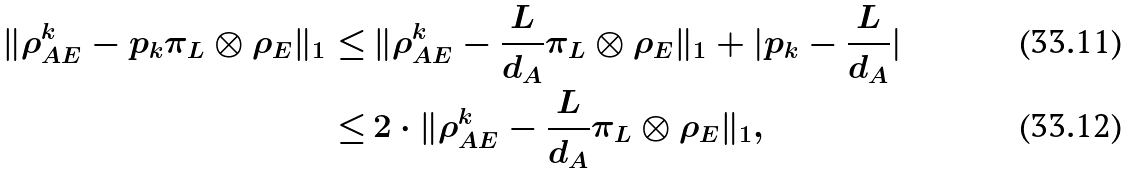<formula> <loc_0><loc_0><loc_500><loc_500>\| \rho _ { A E } ^ { k } - p _ { k } \pi _ { L } \otimes \rho _ { E } \| _ { 1 } \leq & \, \| \rho _ { A E } ^ { k } - \frac { L } { d _ { A } } \pi _ { L } \otimes \rho _ { E } \| _ { 1 } + | p _ { k } - \frac { L } { d _ { A } } | \\ \leq & \, 2 \cdot \| \rho _ { A E } ^ { k } - \frac { L } { d _ { A } } \pi _ { L } \otimes \rho _ { E } \| _ { 1 } ,</formula> 